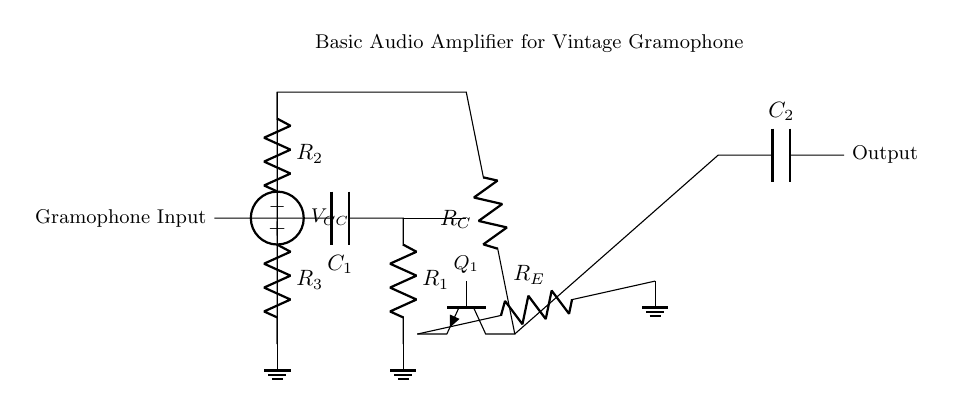What is the type of input component? The input component is a capacitor labeled C1, which is a typical component used for AC signals, allowing them to pass while blocking DC.
Answer: Capacitor What is the function of the resistor R2? Resistor R2 is part of the biasing arrangement for the transistor, setting its operating point to ensure proper amplification characteristics.
Answer: Biasing How many resistors are present in the circuit? The circuit schematic indicates there are three resistors labeled R1, R2, and R3.
Answer: Three What is the role of the transistor labeled Q1? Q1 acts as an amplifier, taking the weak input signal from the gramophone and producing a stronger output signal.
Answer: Amplifier What is the DC supply voltage indicated in the circuit? The circuit shows a DC voltage source labeled VCC providing power to the amplifier. The specific voltage value is not provided, but it is crucial for the transistor operation.
Answer: VCC What happens at the output stage indicated by C2? Capacitor C2 serves to block any DC component from the output, allowing only the amplified AC audio signal to be delivered.
Answer: Blocking DC What type of circuit is presented in this diagram? The circuit is a basic audio amplifier designed to enhance the sound of vintage gramophone recordings by boosting the low-level audio signals.
Answer: Audio amplifier 